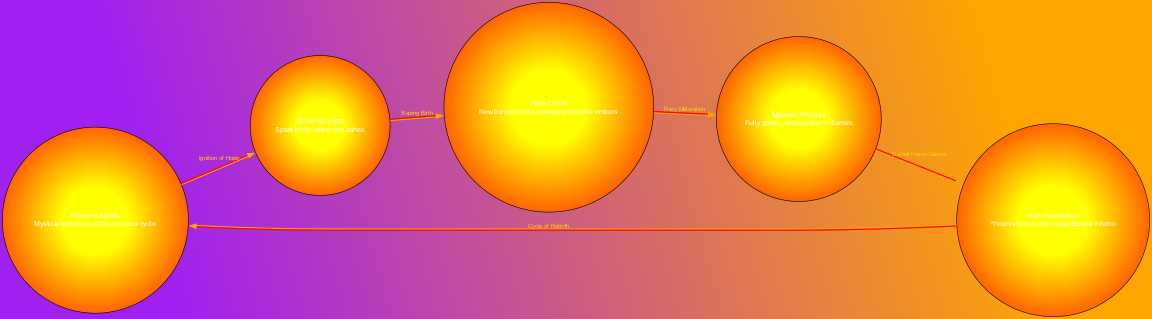What is the first stage in the phoenix life cycle? The diagram indicates that the first stage is represented by the node labeled "Phoenix Ashes." This is where the cycle begins, as it's the mystical remnants of the previous life.
Answer: Phoenix Ashes How many nodes are in the diagram? By counting the nodes listed in the diagram, we find there are five distinct nodes representing different stages of the phoenix's life cycle.
Answer: 5 What does the edge from "Glowing Ember" to "Fiery Chick" signify? The edge between these two nodes is labeled "Blazing Birth," indicating the transformation or transition from the ember stage to the newly born chick stage.
Answer: Blazing Birth What is the label of the edge connecting "Majestic Phoenix" to "Fiery Immolation"? The connection is highlighted by the edge labeled "Eternal Flame Dance," representing the spectacular transformation occurring at this stage in the cycle.
Answer: Eternal Flame Dance In which stage does the cycle conclude before repeating? The diagram shows that after reaching "Phoenix Ashes," the cycle begins anew, indicating that "Fiery Immolation" concludes the cycle before returning to the ashes.
Answer: Fiery Immolation Which node describes the fully grown phoenix? The node labeled "Majestic Phoenix" embodies the fully grown phoenix, resplendent in flames, signifying maturity and brilliance within its life cycle.
Answer: Majestic Phoenix What transformation occurs after "Phoenix Ashes"? The label "Ignition of Hope" signifies the initial transformation from the ashes into a "Glowing Ember," symbolizing a spark of life and renewal.
Answer: Ignition of Hope How do the flames appear in the diagram? The flames are represented by "Swirling fire patterns" that connect the nodes, illustrating the dynamic and ethereal journey of the mythical phoenix through its life cycle.
Answer: Swirling fire patterns What stage precedes the "Adult" phoenix? The diagram indicates that the "Fiery Chick" is the stage that comes directly before the "Majestic Phoenix," representing the growth phase of the phoenix.
Answer: Fiery Chick 